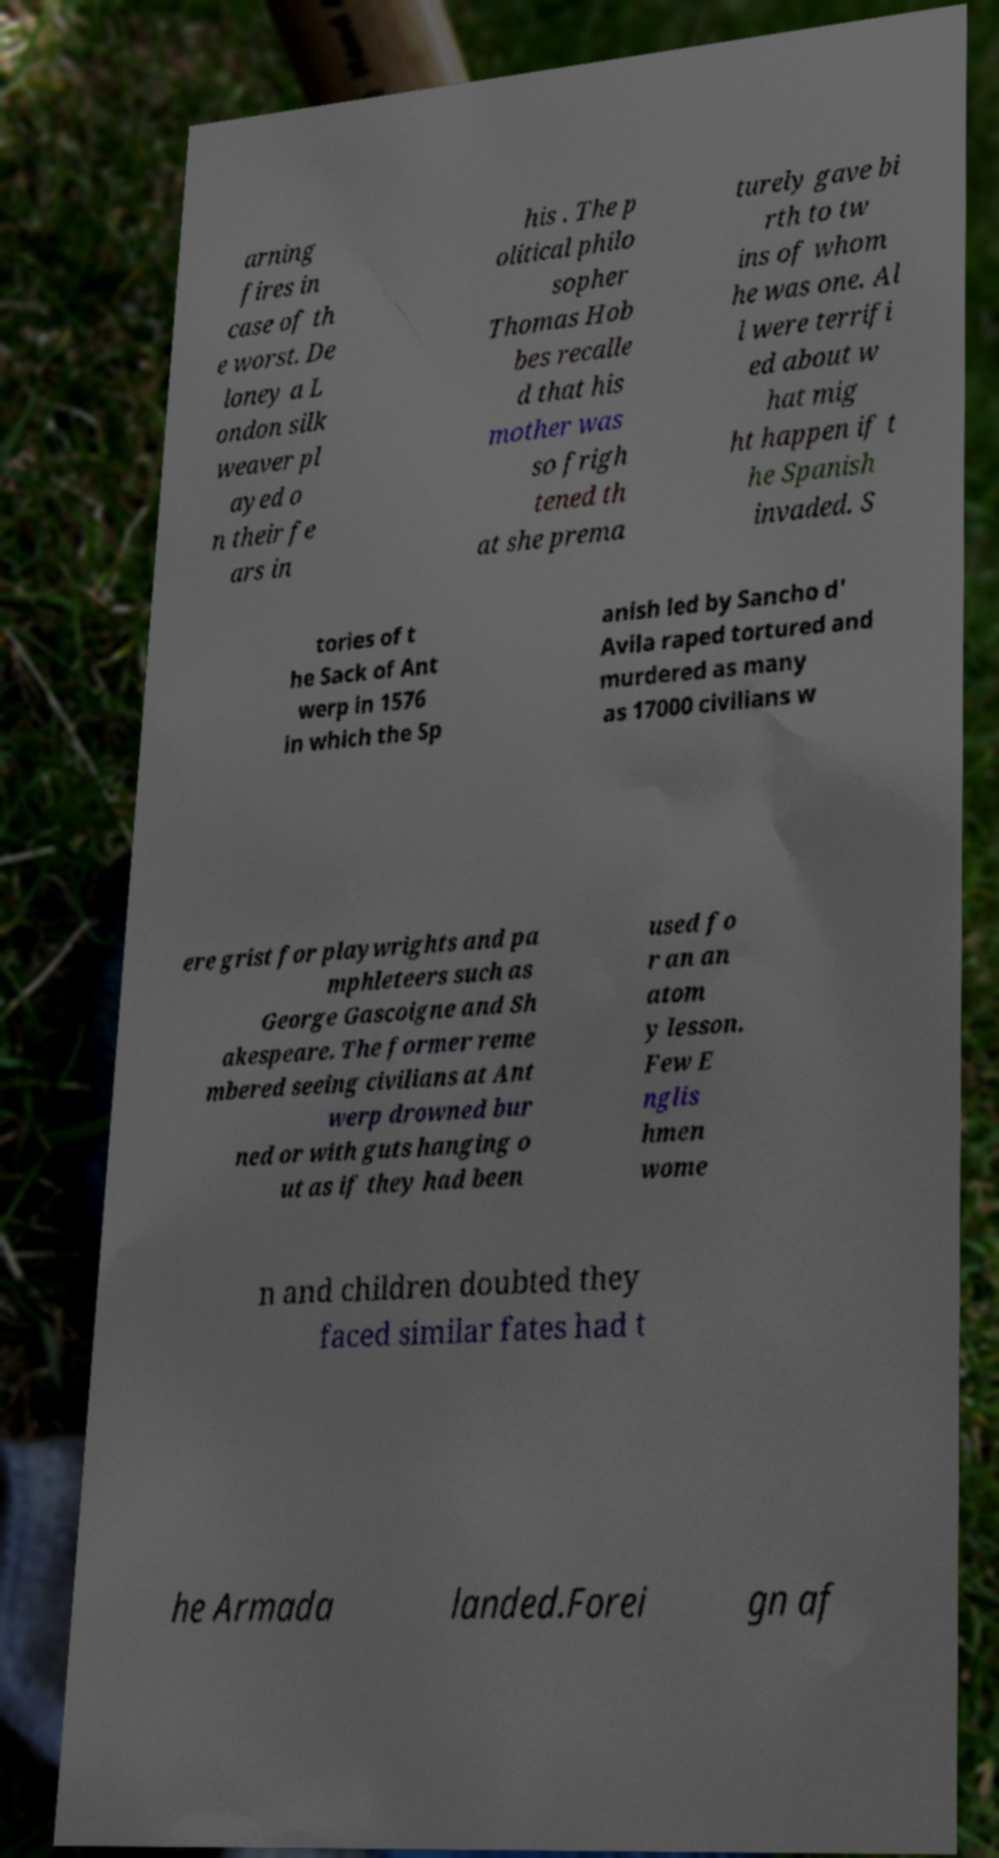Can you read and provide the text displayed in the image?This photo seems to have some interesting text. Can you extract and type it out for me? arning fires in case of th e worst. De loney a L ondon silk weaver pl ayed o n their fe ars in his . The p olitical philo sopher Thomas Hob bes recalle d that his mother was so frigh tened th at she prema turely gave bi rth to tw ins of whom he was one. Al l were terrifi ed about w hat mig ht happen if t he Spanish invaded. S tories of t he Sack of Ant werp in 1576 in which the Sp anish led by Sancho d' Avila raped tortured and murdered as many as 17000 civilians w ere grist for playwrights and pa mphleteers such as George Gascoigne and Sh akespeare. The former reme mbered seeing civilians at Ant werp drowned bur ned or with guts hanging o ut as if they had been used fo r an an atom y lesson. Few E nglis hmen wome n and children doubted they faced similar fates had t he Armada landed.Forei gn af 